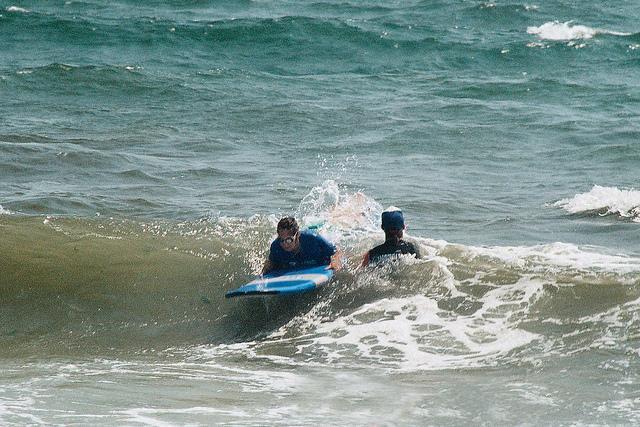How many people can you see?
Give a very brief answer. 2. How many trains are red?
Give a very brief answer. 0. 